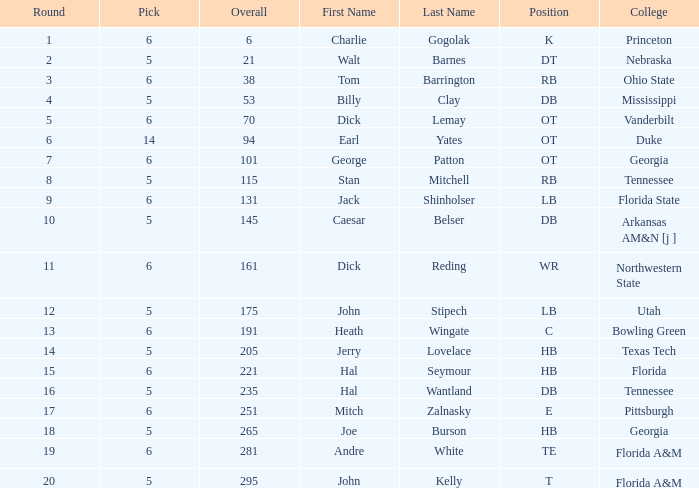What is the total of overall when pick exceeds 5, round is below 11, and the name is "tom barrington"? 38.0. 